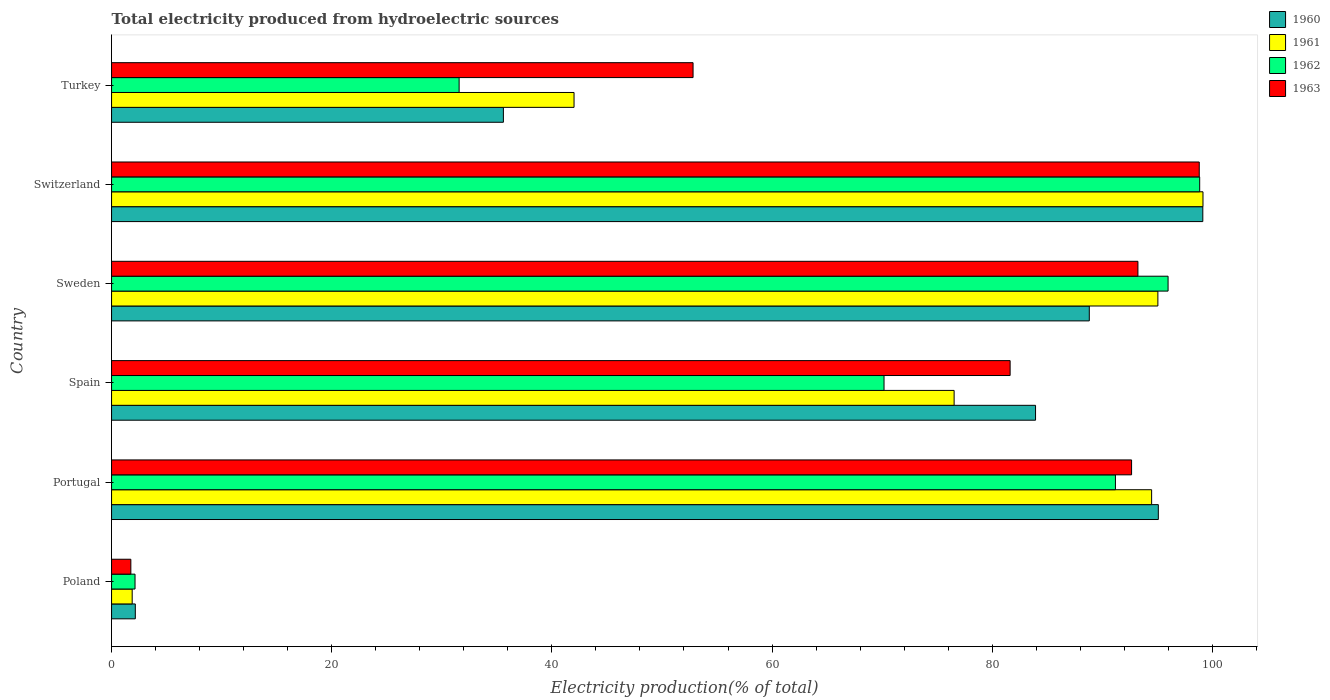How many different coloured bars are there?
Offer a very short reply. 4. Are the number of bars per tick equal to the number of legend labels?
Your answer should be very brief. Yes. Are the number of bars on each tick of the Y-axis equal?
Ensure brevity in your answer.  Yes. How many bars are there on the 1st tick from the top?
Your response must be concise. 4. How many bars are there on the 4th tick from the bottom?
Your answer should be compact. 4. In how many cases, is the number of bars for a given country not equal to the number of legend labels?
Provide a succinct answer. 0. What is the total electricity produced in 1961 in Spain?
Offer a very short reply. 76.54. Across all countries, what is the maximum total electricity produced in 1960?
Give a very brief answer. 99.13. Across all countries, what is the minimum total electricity produced in 1960?
Keep it short and to the point. 2.16. In which country was the total electricity produced in 1963 maximum?
Make the answer very short. Switzerland. In which country was the total electricity produced in 1962 minimum?
Give a very brief answer. Poland. What is the total total electricity produced in 1962 in the graph?
Give a very brief answer. 389.89. What is the difference between the total electricity produced in 1963 in Poland and that in Portugal?
Provide a short and direct response. -90.91. What is the difference between the total electricity produced in 1962 in Poland and the total electricity produced in 1963 in Switzerland?
Your answer should be compact. -96.67. What is the average total electricity produced in 1961 per country?
Offer a very short reply. 68.18. What is the difference between the total electricity produced in 1960 and total electricity produced in 1962 in Poland?
Keep it short and to the point. 0.03. In how many countries, is the total electricity produced in 1962 greater than 96 %?
Your answer should be compact. 1. What is the ratio of the total electricity produced in 1962 in Poland to that in Portugal?
Your answer should be compact. 0.02. Is the difference between the total electricity produced in 1960 in Portugal and Turkey greater than the difference between the total electricity produced in 1962 in Portugal and Turkey?
Provide a succinct answer. No. What is the difference between the highest and the second highest total electricity produced in 1962?
Keep it short and to the point. 2.87. What is the difference between the highest and the lowest total electricity produced in 1960?
Provide a short and direct response. 96.97. In how many countries, is the total electricity produced in 1962 greater than the average total electricity produced in 1962 taken over all countries?
Make the answer very short. 4. Is the sum of the total electricity produced in 1960 in Poland and Turkey greater than the maximum total electricity produced in 1961 across all countries?
Offer a terse response. No. Is it the case that in every country, the sum of the total electricity produced in 1960 and total electricity produced in 1963 is greater than the sum of total electricity produced in 1961 and total electricity produced in 1962?
Your answer should be compact. No. What does the 4th bar from the bottom in Turkey represents?
Provide a short and direct response. 1963. How many bars are there?
Offer a very short reply. 24. How many countries are there in the graph?
Provide a short and direct response. 6. What is the difference between two consecutive major ticks on the X-axis?
Give a very brief answer. 20. What is the title of the graph?
Provide a succinct answer. Total electricity produced from hydroelectric sources. Does "1984" appear as one of the legend labels in the graph?
Give a very brief answer. No. What is the label or title of the X-axis?
Keep it short and to the point. Electricity production(% of total). What is the label or title of the Y-axis?
Your response must be concise. Country. What is the Electricity production(% of total) in 1960 in Poland?
Offer a very short reply. 2.16. What is the Electricity production(% of total) of 1961 in Poland?
Make the answer very short. 1.87. What is the Electricity production(% of total) in 1962 in Poland?
Keep it short and to the point. 2.13. What is the Electricity production(% of total) of 1963 in Poland?
Offer a terse response. 1.75. What is the Electricity production(% of total) in 1960 in Portugal?
Your answer should be very brief. 95.09. What is the Electricity production(% of total) of 1961 in Portugal?
Keep it short and to the point. 94.48. What is the Electricity production(% of total) of 1962 in Portugal?
Give a very brief answer. 91.19. What is the Electricity production(% of total) in 1963 in Portugal?
Your answer should be compact. 92.66. What is the Electricity production(% of total) in 1960 in Spain?
Offer a very short reply. 83.94. What is the Electricity production(% of total) in 1961 in Spain?
Offer a very short reply. 76.54. What is the Electricity production(% of total) of 1962 in Spain?
Your answer should be very brief. 70.17. What is the Electricity production(% of total) of 1963 in Spain?
Provide a succinct answer. 81.63. What is the Electricity production(% of total) of 1960 in Sweden?
Provide a short and direct response. 88.82. What is the Electricity production(% of total) of 1961 in Sweden?
Ensure brevity in your answer.  95.05. What is the Electricity production(% of total) in 1962 in Sweden?
Ensure brevity in your answer.  95.98. What is the Electricity production(% of total) of 1963 in Sweden?
Your answer should be very brief. 93.24. What is the Electricity production(% of total) of 1960 in Switzerland?
Give a very brief answer. 99.13. What is the Electricity production(% of total) in 1961 in Switzerland?
Offer a terse response. 99.15. What is the Electricity production(% of total) of 1962 in Switzerland?
Your response must be concise. 98.85. What is the Electricity production(% of total) in 1963 in Switzerland?
Provide a short and direct response. 98.81. What is the Electricity production(% of total) of 1960 in Turkey?
Your answer should be very brief. 35.6. What is the Electricity production(% of total) in 1961 in Turkey?
Make the answer very short. 42.01. What is the Electricity production(% of total) in 1962 in Turkey?
Ensure brevity in your answer.  31.57. What is the Electricity production(% of total) of 1963 in Turkey?
Offer a very short reply. 52.82. Across all countries, what is the maximum Electricity production(% of total) of 1960?
Offer a very short reply. 99.13. Across all countries, what is the maximum Electricity production(% of total) in 1961?
Provide a succinct answer. 99.15. Across all countries, what is the maximum Electricity production(% of total) in 1962?
Keep it short and to the point. 98.85. Across all countries, what is the maximum Electricity production(% of total) in 1963?
Make the answer very short. 98.81. Across all countries, what is the minimum Electricity production(% of total) of 1960?
Offer a terse response. 2.16. Across all countries, what is the minimum Electricity production(% of total) in 1961?
Provide a short and direct response. 1.87. Across all countries, what is the minimum Electricity production(% of total) in 1962?
Make the answer very short. 2.13. Across all countries, what is the minimum Electricity production(% of total) of 1963?
Provide a succinct answer. 1.75. What is the total Electricity production(% of total) of 1960 in the graph?
Offer a terse response. 404.73. What is the total Electricity production(% of total) of 1961 in the graph?
Provide a short and direct response. 409.1. What is the total Electricity production(% of total) in 1962 in the graph?
Your response must be concise. 389.89. What is the total Electricity production(% of total) of 1963 in the graph?
Your answer should be compact. 420.91. What is the difference between the Electricity production(% of total) in 1960 in Poland and that in Portugal?
Keep it short and to the point. -92.93. What is the difference between the Electricity production(% of total) in 1961 in Poland and that in Portugal?
Give a very brief answer. -92.61. What is the difference between the Electricity production(% of total) of 1962 in Poland and that in Portugal?
Provide a short and direct response. -89.06. What is the difference between the Electricity production(% of total) in 1963 in Poland and that in Portugal?
Give a very brief answer. -90.91. What is the difference between the Electricity production(% of total) in 1960 in Poland and that in Spain?
Your answer should be compact. -81.78. What is the difference between the Electricity production(% of total) in 1961 in Poland and that in Spain?
Offer a very short reply. -74.67. What is the difference between the Electricity production(% of total) of 1962 in Poland and that in Spain?
Make the answer very short. -68.04. What is the difference between the Electricity production(% of total) in 1963 in Poland and that in Spain?
Provide a succinct answer. -79.88. What is the difference between the Electricity production(% of total) of 1960 in Poland and that in Sweden?
Give a very brief answer. -86.66. What is the difference between the Electricity production(% of total) in 1961 in Poland and that in Sweden?
Give a very brief answer. -93.17. What is the difference between the Electricity production(% of total) in 1962 in Poland and that in Sweden?
Keep it short and to the point. -93.84. What is the difference between the Electricity production(% of total) in 1963 in Poland and that in Sweden?
Provide a short and direct response. -91.48. What is the difference between the Electricity production(% of total) in 1960 in Poland and that in Switzerland?
Give a very brief answer. -96.97. What is the difference between the Electricity production(% of total) in 1961 in Poland and that in Switzerland?
Provide a succinct answer. -97.27. What is the difference between the Electricity production(% of total) in 1962 in Poland and that in Switzerland?
Make the answer very short. -96.71. What is the difference between the Electricity production(% of total) of 1963 in Poland and that in Switzerland?
Your answer should be compact. -97.06. What is the difference between the Electricity production(% of total) in 1960 in Poland and that in Turkey?
Provide a succinct answer. -33.44. What is the difference between the Electricity production(% of total) in 1961 in Poland and that in Turkey?
Provide a short and direct response. -40.14. What is the difference between the Electricity production(% of total) in 1962 in Poland and that in Turkey?
Provide a succinct answer. -29.44. What is the difference between the Electricity production(% of total) of 1963 in Poland and that in Turkey?
Make the answer very short. -51.07. What is the difference between the Electricity production(% of total) of 1960 in Portugal and that in Spain?
Your response must be concise. 11.15. What is the difference between the Electricity production(% of total) in 1961 in Portugal and that in Spain?
Make the answer very short. 17.94. What is the difference between the Electricity production(% of total) of 1962 in Portugal and that in Spain?
Give a very brief answer. 21.02. What is the difference between the Electricity production(% of total) of 1963 in Portugal and that in Spain?
Offer a terse response. 11.03. What is the difference between the Electricity production(% of total) in 1960 in Portugal and that in Sweden?
Your answer should be compact. 6.27. What is the difference between the Electricity production(% of total) of 1961 in Portugal and that in Sweden?
Ensure brevity in your answer.  -0.57. What is the difference between the Electricity production(% of total) of 1962 in Portugal and that in Sweden?
Ensure brevity in your answer.  -4.78. What is the difference between the Electricity production(% of total) in 1963 in Portugal and that in Sweden?
Provide a succinct answer. -0.58. What is the difference between the Electricity production(% of total) of 1960 in Portugal and that in Switzerland?
Your response must be concise. -4.04. What is the difference between the Electricity production(% of total) of 1961 in Portugal and that in Switzerland?
Provide a succinct answer. -4.67. What is the difference between the Electricity production(% of total) in 1962 in Portugal and that in Switzerland?
Give a very brief answer. -7.65. What is the difference between the Electricity production(% of total) in 1963 in Portugal and that in Switzerland?
Ensure brevity in your answer.  -6.15. What is the difference between the Electricity production(% of total) of 1960 in Portugal and that in Turkey?
Offer a very short reply. 59.49. What is the difference between the Electricity production(% of total) of 1961 in Portugal and that in Turkey?
Offer a very short reply. 52.47. What is the difference between the Electricity production(% of total) of 1962 in Portugal and that in Turkey?
Your response must be concise. 59.62. What is the difference between the Electricity production(% of total) of 1963 in Portugal and that in Turkey?
Offer a terse response. 39.84. What is the difference between the Electricity production(% of total) in 1960 in Spain and that in Sweden?
Offer a terse response. -4.88. What is the difference between the Electricity production(% of total) in 1961 in Spain and that in Sweden?
Ensure brevity in your answer.  -18.51. What is the difference between the Electricity production(% of total) of 1962 in Spain and that in Sweden?
Keep it short and to the point. -25.8. What is the difference between the Electricity production(% of total) in 1963 in Spain and that in Sweden?
Your answer should be very brief. -11.61. What is the difference between the Electricity production(% of total) in 1960 in Spain and that in Switzerland?
Give a very brief answer. -15.19. What is the difference between the Electricity production(% of total) in 1961 in Spain and that in Switzerland?
Offer a very short reply. -22.61. What is the difference between the Electricity production(% of total) of 1962 in Spain and that in Switzerland?
Give a very brief answer. -28.67. What is the difference between the Electricity production(% of total) of 1963 in Spain and that in Switzerland?
Make the answer very short. -17.18. What is the difference between the Electricity production(% of total) in 1960 in Spain and that in Turkey?
Your answer should be very brief. 48.34. What is the difference between the Electricity production(% of total) of 1961 in Spain and that in Turkey?
Offer a terse response. 34.53. What is the difference between the Electricity production(% of total) of 1962 in Spain and that in Turkey?
Give a very brief answer. 38.6. What is the difference between the Electricity production(% of total) of 1963 in Spain and that in Turkey?
Provide a succinct answer. 28.8. What is the difference between the Electricity production(% of total) in 1960 in Sweden and that in Switzerland?
Your answer should be compact. -10.31. What is the difference between the Electricity production(% of total) of 1961 in Sweden and that in Switzerland?
Make the answer very short. -4.1. What is the difference between the Electricity production(% of total) of 1962 in Sweden and that in Switzerland?
Offer a very short reply. -2.87. What is the difference between the Electricity production(% of total) in 1963 in Sweden and that in Switzerland?
Give a very brief answer. -5.57. What is the difference between the Electricity production(% of total) in 1960 in Sweden and that in Turkey?
Provide a short and direct response. 53.22. What is the difference between the Electricity production(% of total) of 1961 in Sweden and that in Turkey?
Provide a short and direct response. 53.04. What is the difference between the Electricity production(% of total) of 1962 in Sweden and that in Turkey?
Keep it short and to the point. 64.4. What is the difference between the Electricity production(% of total) of 1963 in Sweden and that in Turkey?
Ensure brevity in your answer.  40.41. What is the difference between the Electricity production(% of total) in 1960 in Switzerland and that in Turkey?
Your response must be concise. 63.54. What is the difference between the Electricity production(% of total) in 1961 in Switzerland and that in Turkey?
Give a very brief answer. 57.13. What is the difference between the Electricity production(% of total) of 1962 in Switzerland and that in Turkey?
Offer a terse response. 67.27. What is the difference between the Electricity production(% of total) of 1963 in Switzerland and that in Turkey?
Provide a short and direct response. 45.98. What is the difference between the Electricity production(% of total) of 1960 in Poland and the Electricity production(% of total) of 1961 in Portugal?
Provide a succinct answer. -92.32. What is the difference between the Electricity production(% of total) of 1960 in Poland and the Electricity production(% of total) of 1962 in Portugal?
Ensure brevity in your answer.  -89.03. What is the difference between the Electricity production(% of total) of 1960 in Poland and the Electricity production(% of total) of 1963 in Portugal?
Make the answer very short. -90.5. What is the difference between the Electricity production(% of total) in 1961 in Poland and the Electricity production(% of total) in 1962 in Portugal?
Provide a succinct answer. -89.32. What is the difference between the Electricity production(% of total) of 1961 in Poland and the Electricity production(% of total) of 1963 in Portugal?
Your response must be concise. -90.79. What is the difference between the Electricity production(% of total) of 1962 in Poland and the Electricity production(% of total) of 1963 in Portugal?
Offer a terse response. -90.53. What is the difference between the Electricity production(% of total) of 1960 in Poland and the Electricity production(% of total) of 1961 in Spain?
Provide a short and direct response. -74.38. What is the difference between the Electricity production(% of total) of 1960 in Poland and the Electricity production(% of total) of 1962 in Spain?
Keep it short and to the point. -68.01. What is the difference between the Electricity production(% of total) of 1960 in Poland and the Electricity production(% of total) of 1963 in Spain?
Give a very brief answer. -79.47. What is the difference between the Electricity production(% of total) of 1961 in Poland and the Electricity production(% of total) of 1962 in Spain?
Provide a short and direct response. -68.3. What is the difference between the Electricity production(% of total) in 1961 in Poland and the Electricity production(% of total) in 1963 in Spain?
Your answer should be very brief. -79.75. What is the difference between the Electricity production(% of total) in 1962 in Poland and the Electricity production(% of total) in 1963 in Spain?
Keep it short and to the point. -79.5. What is the difference between the Electricity production(% of total) of 1960 in Poland and the Electricity production(% of total) of 1961 in Sweden?
Provide a short and direct response. -92.89. What is the difference between the Electricity production(% of total) of 1960 in Poland and the Electricity production(% of total) of 1962 in Sweden?
Your response must be concise. -93.82. What is the difference between the Electricity production(% of total) of 1960 in Poland and the Electricity production(% of total) of 1963 in Sweden?
Your answer should be very brief. -91.08. What is the difference between the Electricity production(% of total) in 1961 in Poland and the Electricity production(% of total) in 1962 in Sweden?
Provide a succinct answer. -94.1. What is the difference between the Electricity production(% of total) in 1961 in Poland and the Electricity production(% of total) in 1963 in Sweden?
Provide a succinct answer. -91.36. What is the difference between the Electricity production(% of total) in 1962 in Poland and the Electricity production(% of total) in 1963 in Sweden?
Keep it short and to the point. -91.1. What is the difference between the Electricity production(% of total) in 1960 in Poland and the Electricity production(% of total) in 1961 in Switzerland?
Give a very brief answer. -96.99. What is the difference between the Electricity production(% of total) of 1960 in Poland and the Electricity production(% of total) of 1962 in Switzerland?
Provide a succinct answer. -96.69. What is the difference between the Electricity production(% of total) of 1960 in Poland and the Electricity production(% of total) of 1963 in Switzerland?
Keep it short and to the point. -96.65. What is the difference between the Electricity production(% of total) of 1961 in Poland and the Electricity production(% of total) of 1962 in Switzerland?
Provide a short and direct response. -96.97. What is the difference between the Electricity production(% of total) in 1961 in Poland and the Electricity production(% of total) in 1963 in Switzerland?
Provide a short and direct response. -96.93. What is the difference between the Electricity production(% of total) in 1962 in Poland and the Electricity production(% of total) in 1963 in Switzerland?
Offer a very short reply. -96.67. What is the difference between the Electricity production(% of total) of 1960 in Poland and the Electricity production(% of total) of 1961 in Turkey?
Make the answer very short. -39.85. What is the difference between the Electricity production(% of total) in 1960 in Poland and the Electricity production(% of total) in 1962 in Turkey?
Give a very brief answer. -29.41. What is the difference between the Electricity production(% of total) in 1960 in Poland and the Electricity production(% of total) in 1963 in Turkey?
Ensure brevity in your answer.  -50.67. What is the difference between the Electricity production(% of total) in 1961 in Poland and the Electricity production(% of total) in 1962 in Turkey?
Provide a succinct answer. -29.7. What is the difference between the Electricity production(% of total) of 1961 in Poland and the Electricity production(% of total) of 1963 in Turkey?
Provide a succinct answer. -50.95. What is the difference between the Electricity production(% of total) of 1962 in Poland and the Electricity production(% of total) of 1963 in Turkey?
Your response must be concise. -50.69. What is the difference between the Electricity production(% of total) of 1960 in Portugal and the Electricity production(% of total) of 1961 in Spain?
Provide a short and direct response. 18.55. What is the difference between the Electricity production(% of total) in 1960 in Portugal and the Electricity production(% of total) in 1962 in Spain?
Your answer should be compact. 24.92. What is the difference between the Electricity production(% of total) in 1960 in Portugal and the Electricity production(% of total) in 1963 in Spain?
Your answer should be compact. 13.46. What is the difference between the Electricity production(% of total) of 1961 in Portugal and the Electricity production(% of total) of 1962 in Spain?
Provide a short and direct response. 24.31. What is the difference between the Electricity production(% of total) of 1961 in Portugal and the Electricity production(% of total) of 1963 in Spain?
Give a very brief answer. 12.85. What is the difference between the Electricity production(% of total) in 1962 in Portugal and the Electricity production(% of total) in 1963 in Spain?
Your answer should be very brief. 9.57. What is the difference between the Electricity production(% of total) of 1960 in Portugal and the Electricity production(% of total) of 1961 in Sweden?
Your response must be concise. 0.04. What is the difference between the Electricity production(% of total) of 1960 in Portugal and the Electricity production(% of total) of 1962 in Sweden?
Give a very brief answer. -0.89. What is the difference between the Electricity production(% of total) of 1960 in Portugal and the Electricity production(% of total) of 1963 in Sweden?
Provide a short and direct response. 1.85. What is the difference between the Electricity production(% of total) of 1961 in Portugal and the Electricity production(% of total) of 1962 in Sweden?
Offer a very short reply. -1.49. What is the difference between the Electricity production(% of total) of 1961 in Portugal and the Electricity production(% of total) of 1963 in Sweden?
Your answer should be compact. 1.24. What is the difference between the Electricity production(% of total) in 1962 in Portugal and the Electricity production(% of total) in 1963 in Sweden?
Your answer should be very brief. -2.04. What is the difference between the Electricity production(% of total) of 1960 in Portugal and the Electricity production(% of total) of 1961 in Switzerland?
Keep it short and to the point. -4.06. What is the difference between the Electricity production(% of total) of 1960 in Portugal and the Electricity production(% of total) of 1962 in Switzerland?
Give a very brief answer. -3.76. What is the difference between the Electricity production(% of total) of 1960 in Portugal and the Electricity production(% of total) of 1963 in Switzerland?
Provide a short and direct response. -3.72. What is the difference between the Electricity production(% of total) in 1961 in Portugal and the Electricity production(% of total) in 1962 in Switzerland?
Give a very brief answer. -4.37. What is the difference between the Electricity production(% of total) in 1961 in Portugal and the Electricity production(% of total) in 1963 in Switzerland?
Offer a terse response. -4.33. What is the difference between the Electricity production(% of total) in 1962 in Portugal and the Electricity production(% of total) in 1963 in Switzerland?
Keep it short and to the point. -7.61. What is the difference between the Electricity production(% of total) in 1960 in Portugal and the Electricity production(% of total) in 1961 in Turkey?
Give a very brief answer. 53.08. What is the difference between the Electricity production(% of total) in 1960 in Portugal and the Electricity production(% of total) in 1962 in Turkey?
Your answer should be compact. 63.52. What is the difference between the Electricity production(% of total) in 1960 in Portugal and the Electricity production(% of total) in 1963 in Turkey?
Keep it short and to the point. 42.27. What is the difference between the Electricity production(% of total) of 1961 in Portugal and the Electricity production(% of total) of 1962 in Turkey?
Your response must be concise. 62.91. What is the difference between the Electricity production(% of total) in 1961 in Portugal and the Electricity production(% of total) in 1963 in Turkey?
Ensure brevity in your answer.  41.66. What is the difference between the Electricity production(% of total) in 1962 in Portugal and the Electricity production(% of total) in 1963 in Turkey?
Make the answer very short. 38.37. What is the difference between the Electricity production(% of total) of 1960 in Spain and the Electricity production(% of total) of 1961 in Sweden?
Give a very brief answer. -11.11. What is the difference between the Electricity production(% of total) in 1960 in Spain and the Electricity production(% of total) in 1962 in Sweden?
Provide a succinct answer. -12.04. What is the difference between the Electricity production(% of total) in 1960 in Spain and the Electricity production(% of total) in 1963 in Sweden?
Your answer should be compact. -9.3. What is the difference between the Electricity production(% of total) of 1961 in Spain and the Electricity production(% of total) of 1962 in Sweden?
Your answer should be very brief. -19.44. What is the difference between the Electricity production(% of total) of 1961 in Spain and the Electricity production(% of total) of 1963 in Sweden?
Offer a very short reply. -16.7. What is the difference between the Electricity production(% of total) of 1962 in Spain and the Electricity production(% of total) of 1963 in Sweden?
Keep it short and to the point. -23.06. What is the difference between the Electricity production(% of total) of 1960 in Spain and the Electricity production(% of total) of 1961 in Switzerland?
Offer a terse response. -15.21. What is the difference between the Electricity production(% of total) of 1960 in Spain and the Electricity production(% of total) of 1962 in Switzerland?
Give a very brief answer. -14.91. What is the difference between the Electricity production(% of total) in 1960 in Spain and the Electricity production(% of total) in 1963 in Switzerland?
Your response must be concise. -14.87. What is the difference between the Electricity production(% of total) in 1961 in Spain and the Electricity production(% of total) in 1962 in Switzerland?
Give a very brief answer. -22.31. What is the difference between the Electricity production(% of total) of 1961 in Spain and the Electricity production(% of total) of 1963 in Switzerland?
Make the answer very short. -22.27. What is the difference between the Electricity production(% of total) in 1962 in Spain and the Electricity production(% of total) in 1963 in Switzerland?
Keep it short and to the point. -28.63. What is the difference between the Electricity production(% of total) of 1960 in Spain and the Electricity production(% of total) of 1961 in Turkey?
Provide a short and direct response. 41.92. What is the difference between the Electricity production(% of total) in 1960 in Spain and the Electricity production(% of total) in 1962 in Turkey?
Your answer should be compact. 52.36. What is the difference between the Electricity production(% of total) in 1960 in Spain and the Electricity production(% of total) in 1963 in Turkey?
Provide a short and direct response. 31.11. What is the difference between the Electricity production(% of total) in 1961 in Spain and the Electricity production(% of total) in 1962 in Turkey?
Keep it short and to the point. 44.97. What is the difference between the Electricity production(% of total) in 1961 in Spain and the Electricity production(% of total) in 1963 in Turkey?
Your answer should be compact. 23.72. What is the difference between the Electricity production(% of total) of 1962 in Spain and the Electricity production(% of total) of 1963 in Turkey?
Provide a short and direct response. 17.35. What is the difference between the Electricity production(% of total) of 1960 in Sweden and the Electricity production(% of total) of 1961 in Switzerland?
Keep it short and to the point. -10.33. What is the difference between the Electricity production(% of total) in 1960 in Sweden and the Electricity production(% of total) in 1962 in Switzerland?
Give a very brief answer. -10.03. What is the difference between the Electricity production(% of total) in 1960 in Sweden and the Electricity production(% of total) in 1963 in Switzerland?
Give a very brief answer. -9.99. What is the difference between the Electricity production(% of total) of 1961 in Sweden and the Electricity production(% of total) of 1962 in Switzerland?
Provide a short and direct response. -3.8. What is the difference between the Electricity production(% of total) of 1961 in Sweden and the Electricity production(% of total) of 1963 in Switzerland?
Make the answer very short. -3.76. What is the difference between the Electricity production(% of total) in 1962 in Sweden and the Electricity production(% of total) in 1963 in Switzerland?
Your response must be concise. -2.83. What is the difference between the Electricity production(% of total) of 1960 in Sweden and the Electricity production(% of total) of 1961 in Turkey?
Your answer should be compact. 46.81. What is the difference between the Electricity production(% of total) in 1960 in Sweden and the Electricity production(% of total) in 1962 in Turkey?
Your answer should be compact. 57.25. What is the difference between the Electricity production(% of total) in 1960 in Sweden and the Electricity production(% of total) in 1963 in Turkey?
Keep it short and to the point. 36. What is the difference between the Electricity production(% of total) of 1961 in Sweden and the Electricity production(% of total) of 1962 in Turkey?
Provide a short and direct response. 63.48. What is the difference between the Electricity production(% of total) in 1961 in Sweden and the Electricity production(% of total) in 1963 in Turkey?
Provide a short and direct response. 42.22. What is the difference between the Electricity production(% of total) of 1962 in Sweden and the Electricity production(% of total) of 1963 in Turkey?
Ensure brevity in your answer.  43.15. What is the difference between the Electricity production(% of total) in 1960 in Switzerland and the Electricity production(% of total) in 1961 in Turkey?
Your answer should be very brief. 57.12. What is the difference between the Electricity production(% of total) of 1960 in Switzerland and the Electricity production(% of total) of 1962 in Turkey?
Ensure brevity in your answer.  67.56. What is the difference between the Electricity production(% of total) in 1960 in Switzerland and the Electricity production(% of total) in 1963 in Turkey?
Provide a short and direct response. 46.31. What is the difference between the Electricity production(% of total) in 1961 in Switzerland and the Electricity production(% of total) in 1962 in Turkey?
Keep it short and to the point. 67.57. What is the difference between the Electricity production(% of total) in 1961 in Switzerland and the Electricity production(% of total) in 1963 in Turkey?
Your answer should be compact. 46.32. What is the difference between the Electricity production(% of total) in 1962 in Switzerland and the Electricity production(% of total) in 1963 in Turkey?
Provide a succinct answer. 46.02. What is the average Electricity production(% of total) in 1960 per country?
Your answer should be compact. 67.45. What is the average Electricity production(% of total) in 1961 per country?
Make the answer very short. 68.18. What is the average Electricity production(% of total) in 1962 per country?
Ensure brevity in your answer.  64.98. What is the average Electricity production(% of total) of 1963 per country?
Offer a very short reply. 70.15. What is the difference between the Electricity production(% of total) in 1960 and Electricity production(% of total) in 1961 in Poland?
Offer a terse response. 0.28. What is the difference between the Electricity production(% of total) of 1960 and Electricity production(% of total) of 1962 in Poland?
Offer a very short reply. 0.03. What is the difference between the Electricity production(% of total) of 1960 and Electricity production(% of total) of 1963 in Poland?
Your answer should be compact. 0.41. What is the difference between the Electricity production(% of total) of 1961 and Electricity production(% of total) of 1962 in Poland?
Ensure brevity in your answer.  -0.26. What is the difference between the Electricity production(% of total) of 1961 and Electricity production(% of total) of 1963 in Poland?
Provide a succinct answer. 0.12. What is the difference between the Electricity production(% of total) in 1962 and Electricity production(% of total) in 1963 in Poland?
Make the answer very short. 0.38. What is the difference between the Electricity production(% of total) of 1960 and Electricity production(% of total) of 1961 in Portugal?
Make the answer very short. 0.61. What is the difference between the Electricity production(% of total) of 1960 and Electricity production(% of total) of 1962 in Portugal?
Provide a succinct answer. 3.9. What is the difference between the Electricity production(% of total) in 1960 and Electricity production(% of total) in 1963 in Portugal?
Your answer should be very brief. 2.43. What is the difference between the Electricity production(% of total) of 1961 and Electricity production(% of total) of 1962 in Portugal?
Make the answer very short. 3.29. What is the difference between the Electricity production(% of total) of 1961 and Electricity production(% of total) of 1963 in Portugal?
Make the answer very short. 1.82. What is the difference between the Electricity production(% of total) of 1962 and Electricity production(% of total) of 1963 in Portugal?
Offer a terse response. -1.47. What is the difference between the Electricity production(% of total) of 1960 and Electricity production(% of total) of 1961 in Spain?
Give a very brief answer. 7.4. What is the difference between the Electricity production(% of total) in 1960 and Electricity production(% of total) in 1962 in Spain?
Provide a succinct answer. 13.76. What is the difference between the Electricity production(% of total) in 1960 and Electricity production(% of total) in 1963 in Spain?
Offer a very short reply. 2.31. What is the difference between the Electricity production(% of total) in 1961 and Electricity production(% of total) in 1962 in Spain?
Offer a terse response. 6.37. What is the difference between the Electricity production(% of total) of 1961 and Electricity production(% of total) of 1963 in Spain?
Offer a terse response. -5.09. What is the difference between the Electricity production(% of total) of 1962 and Electricity production(% of total) of 1963 in Spain?
Give a very brief answer. -11.45. What is the difference between the Electricity production(% of total) of 1960 and Electricity production(% of total) of 1961 in Sweden?
Your answer should be compact. -6.23. What is the difference between the Electricity production(% of total) in 1960 and Electricity production(% of total) in 1962 in Sweden?
Your answer should be very brief. -7.16. What is the difference between the Electricity production(% of total) in 1960 and Electricity production(% of total) in 1963 in Sweden?
Your answer should be compact. -4.42. What is the difference between the Electricity production(% of total) of 1961 and Electricity production(% of total) of 1962 in Sweden?
Offer a terse response. -0.93. What is the difference between the Electricity production(% of total) of 1961 and Electricity production(% of total) of 1963 in Sweden?
Give a very brief answer. 1.81. What is the difference between the Electricity production(% of total) in 1962 and Electricity production(% of total) in 1963 in Sweden?
Keep it short and to the point. 2.74. What is the difference between the Electricity production(% of total) in 1960 and Electricity production(% of total) in 1961 in Switzerland?
Your response must be concise. -0.02. What is the difference between the Electricity production(% of total) of 1960 and Electricity production(% of total) of 1962 in Switzerland?
Give a very brief answer. 0.28. What is the difference between the Electricity production(% of total) of 1960 and Electricity production(% of total) of 1963 in Switzerland?
Offer a very short reply. 0.32. What is the difference between the Electricity production(% of total) of 1961 and Electricity production(% of total) of 1962 in Switzerland?
Make the answer very short. 0.3. What is the difference between the Electricity production(% of total) of 1961 and Electricity production(% of total) of 1963 in Switzerland?
Keep it short and to the point. 0.34. What is the difference between the Electricity production(% of total) of 1962 and Electricity production(% of total) of 1963 in Switzerland?
Offer a very short reply. 0.04. What is the difference between the Electricity production(% of total) of 1960 and Electricity production(% of total) of 1961 in Turkey?
Offer a very short reply. -6.42. What is the difference between the Electricity production(% of total) in 1960 and Electricity production(% of total) in 1962 in Turkey?
Ensure brevity in your answer.  4.02. What is the difference between the Electricity production(% of total) in 1960 and Electricity production(% of total) in 1963 in Turkey?
Make the answer very short. -17.23. What is the difference between the Electricity production(% of total) in 1961 and Electricity production(% of total) in 1962 in Turkey?
Provide a succinct answer. 10.44. What is the difference between the Electricity production(% of total) in 1961 and Electricity production(% of total) in 1963 in Turkey?
Offer a terse response. -10.81. What is the difference between the Electricity production(% of total) of 1962 and Electricity production(% of total) of 1963 in Turkey?
Your answer should be compact. -21.25. What is the ratio of the Electricity production(% of total) in 1960 in Poland to that in Portugal?
Provide a succinct answer. 0.02. What is the ratio of the Electricity production(% of total) in 1961 in Poland to that in Portugal?
Ensure brevity in your answer.  0.02. What is the ratio of the Electricity production(% of total) in 1962 in Poland to that in Portugal?
Provide a short and direct response. 0.02. What is the ratio of the Electricity production(% of total) in 1963 in Poland to that in Portugal?
Provide a short and direct response. 0.02. What is the ratio of the Electricity production(% of total) in 1960 in Poland to that in Spain?
Your answer should be compact. 0.03. What is the ratio of the Electricity production(% of total) in 1961 in Poland to that in Spain?
Provide a succinct answer. 0.02. What is the ratio of the Electricity production(% of total) of 1962 in Poland to that in Spain?
Ensure brevity in your answer.  0.03. What is the ratio of the Electricity production(% of total) in 1963 in Poland to that in Spain?
Give a very brief answer. 0.02. What is the ratio of the Electricity production(% of total) of 1960 in Poland to that in Sweden?
Offer a very short reply. 0.02. What is the ratio of the Electricity production(% of total) in 1961 in Poland to that in Sweden?
Your answer should be compact. 0.02. What is the ratio of the Electricity production(% of total) of 1962 in Poland to that in Sweden?
Offer a very short reply. 0.02. What is the ratio of the Electricity production(% of total) in 1963 in Poland to that in Sweden?
Keep it short and to the point. 0.02. What is the ratio of the Electricity production(% of total) of 1960 in Poland to that in Switzerland?
Your answer should be very brief. 0.02. What is the ratio of the Electricity production(% of total) of 1961 in Poland to that in Switzerland?
Your response must be concise. 0.02. What is the ratio of the Electricity production(% of total) of 1962 in Poland to that in Switzerland?
Your response must be concise. 0.02. What is the ratio of the Electricity production(% of total) of 1963 in Poland to that in Switzerland?
Provide a succinct answer. 0.02. What is the ratio of the Electricity production(% of total) in 1960 in Poland to that in Turkey?
Offer a terse response. 0.06. What is the ratio of the Electricity production(% of total) in 1961 in Poland to that in Turkey?
Your response must be concise. 0.04. What is the ratio of the Electricity production(% of total) in 1962 in Poland to that in Turkey?
Your answer should be very brief. 0.07. What is the ratio of the Electricity production(% of total) in 1963 in Poland to that in Turkey?
Keep it short and to the point. 0.03. What is the ratio of the Electricity production(% of total) in 1960 in Portugal to that in Spain?
Offer a terse response. 1.13. What is the ratio of the Electricity production(% of total) in 1961 in Portugal to that in Spain?
Offer a very short reply. 1.23. What is the ratio of the Electricity production(% of total) of 1962 in Portugal to that in Spain?
Your answer should be very brief. 1.3. What is the ratio of the Electricity production(% of total) of 1963 in Portugal to that in Spain?
Provide a short and direct response. 1.14. What is the ratio of the Electricity production(% of total) in 1960 in Portugal to that in Sweden?
Provide a succinct answer. 1.07. What is the ratio of the Electricity production(% of total) in 1961 in Portugal to that in Sweden?
Your answer should be compact. 0.99. What is the ratio of the Electricity production(% of total) of 1962 in Portugal to that in Sweden?
Your response must be concise. 0.95. What is the ratio of the Electricity production(% of total) of 1960 in Portugal to that in Switzerland?
Give a very brief answer. 0.96. What is the ratio of the Electricity production(% of total) in 1961 in Portugal to that in Switzerland?
Give a very brief answer. 0.95. What is the ratio of the Electricity production(% of total) in 1962 in Portugal to that in Switzerland?
Keep it short and to the point. 0.92. What is the ratio of the Electricity production(% of total) of 1963 in Portugal to that in Switzerland?
Make the answer very short. 0.94. What is the ratio of the Electricity production(% of total) of 1960 in Portugal to that in Turkey?
Provide a succinct answer. 2.67. What is the ratio of the Electricity production(% of total) in 1961 in Portugal to that in Turkey?
Provide a short and direct response. 2.25. What is the ratio of the Electricity production(% of total) in 1962 in Portugal to that in Turkey?
Give a very brief answer. 2.89. What is the ratio of the Electricity production(% of total) of 1963 in Portugal to that in Turkey?
Ensure brevity in your answer.  1.75. What is the ratio of the Electricity production(% of total) in 1960 in Spain to that in Sweden?
Your response must be concise. 0.94. What is the ratio of the Electricity production(% of total) of 1961 in Spain to that in Sweden?
Your answer should be compact. 0.81. What is the ratio of the Electricity production(% of total) in 1962 in Spain to that in Sweden?
Provide a succinct answer. 0.73. What is the ratio of the Electricity production(% of total) of 1963 in Spain to that in Sweden?
Give a very brief answer. 0.88. What is the ratio of the Electricity production(% of total) in 1960 in Spain to that in Switzerland?
Provide a succinct answer. 0.85. What is the ratio of the Electricity production(% of total) in 1961 in Spain to that in Switzerland?
Offer a very short reply. 0.77. What is the ratio of the Electricity production(% of total) in 1962 in Spain to that in Switzerland?
Ensure brevity in your answer.  0.71. What is the ratio of the Electricity production(% of total) in 1963 in Spain to that in Switzerland?
Keep it short and to the point. 0.83. What is the ratio of the Electricity production(% of total) in 1960 in Spain to that in Turkey?
Your response must be concise. 2.36. What is the ratio of the Electricity production(% of total) of 1961 in Spain to that in Turkey?
Your answer should be very brief. 1.82. What is the ratio of the Electricity production(% of total) of 1962 in Spain to that in Turkey?
Offer a terse response. 2.22. What is the ratio of the Electricity production(% of total) of 1963 in Spain to that in Turkey?
Make the answer very short. 1.55. What is the ratio of the Electricity production(% of total) in 1960 in Sweden to that in Switzerland?
Offer a terse response. 0.9. What is the ratio of the Electricity production(% of total) in 1961 in Sweden to that in Switzerland?
Your answer should be compact. 0.96. What is the ratio of the Electricity production(% of total) of 1962 in Sweden to that in Switzerland?
Your answer should be very brief. 0.97. What is the ratio of the Electricity production(% of total) of 1963 in Sweden to that in Switzerland?
Your answer should be very brief. 0.94. What is the ratio of the Electricity production(% of total) in 1960 in Sweden to that in Turkey?
Provide a short and direct response. 2.5. What is the ratio of the Electricity production(% of total) in 1961 in Sweden to that in Turkey?
Provide a succinct answer. 2.26. What is the ratio of the Electricity production(% of total) of 1962 in Sweden to that in Turkey?
Offer a terse response. 3.04. What is the ratio of the Electricity production(% of total) in 1963 in Sweden to that in Turkey?
Your answer should be very brief. 1.76. What is the ratio of the Electricity production(% of total) of 1960 in Switzerland to that in Turkey?
Your answer should be very brief. 2.79. What is the ratio of the Electricity production(% of total) of 1961 in Switzerland to that in Turkey?
Offer a very short reply. 2.36. What is the ratio of the Electricity production(% of total) in 1962 in Switzerland to that in Turkey?
Offer a very short reply. 3.13. What is the ratio of the Electricity production(% of total) of 1963 in Switzerland to that in Turkey?
Your answer should be compact. 1.87. What is the difference between the highest and the second highest Electricity production(% of total) in 1960?
Make the answer very short. 4.04. What is the difference between the highest and the second highest Electricity production(% of total) of 1961?
Make the answer very short. 4.1. What is the difference between the highest and the second highest Electricity production(% of total) in 1962?
Ensure brevity in your answer.  2.87. What is the difference between the highest and the second highest Electricity production(% of total) of 1963?
Give a very brief answer. 5.57. What is the difference between the highest and the lowest Electricity production(% of total) in 1960?
Your response must be concise. 96.97. What is the difference between the highest and the lowest Electricity production(% of total) in 1961?
Your answer should be very brief. 97.27. What is the difference between the highest and the lowest Electricity production(% of total) in 1962?
Your answer should be compact. 96.71. What is the difference between the highest and the lowest Electricity production(% of total) in 1963?
Your answer should be very brief. 97.06. 